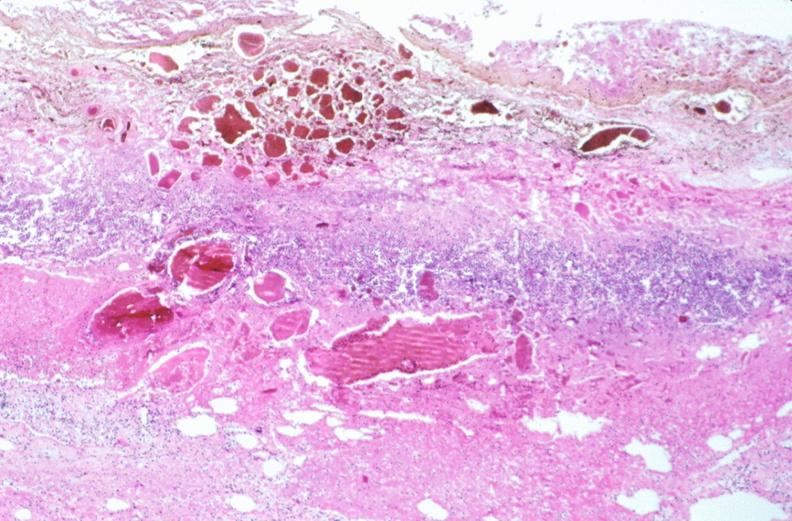does slide show stomach, necrotizing esophagitis and gastritis, sulfuric acid ingested as suicide attempt?
Answer the question using a single word or phrase. No 